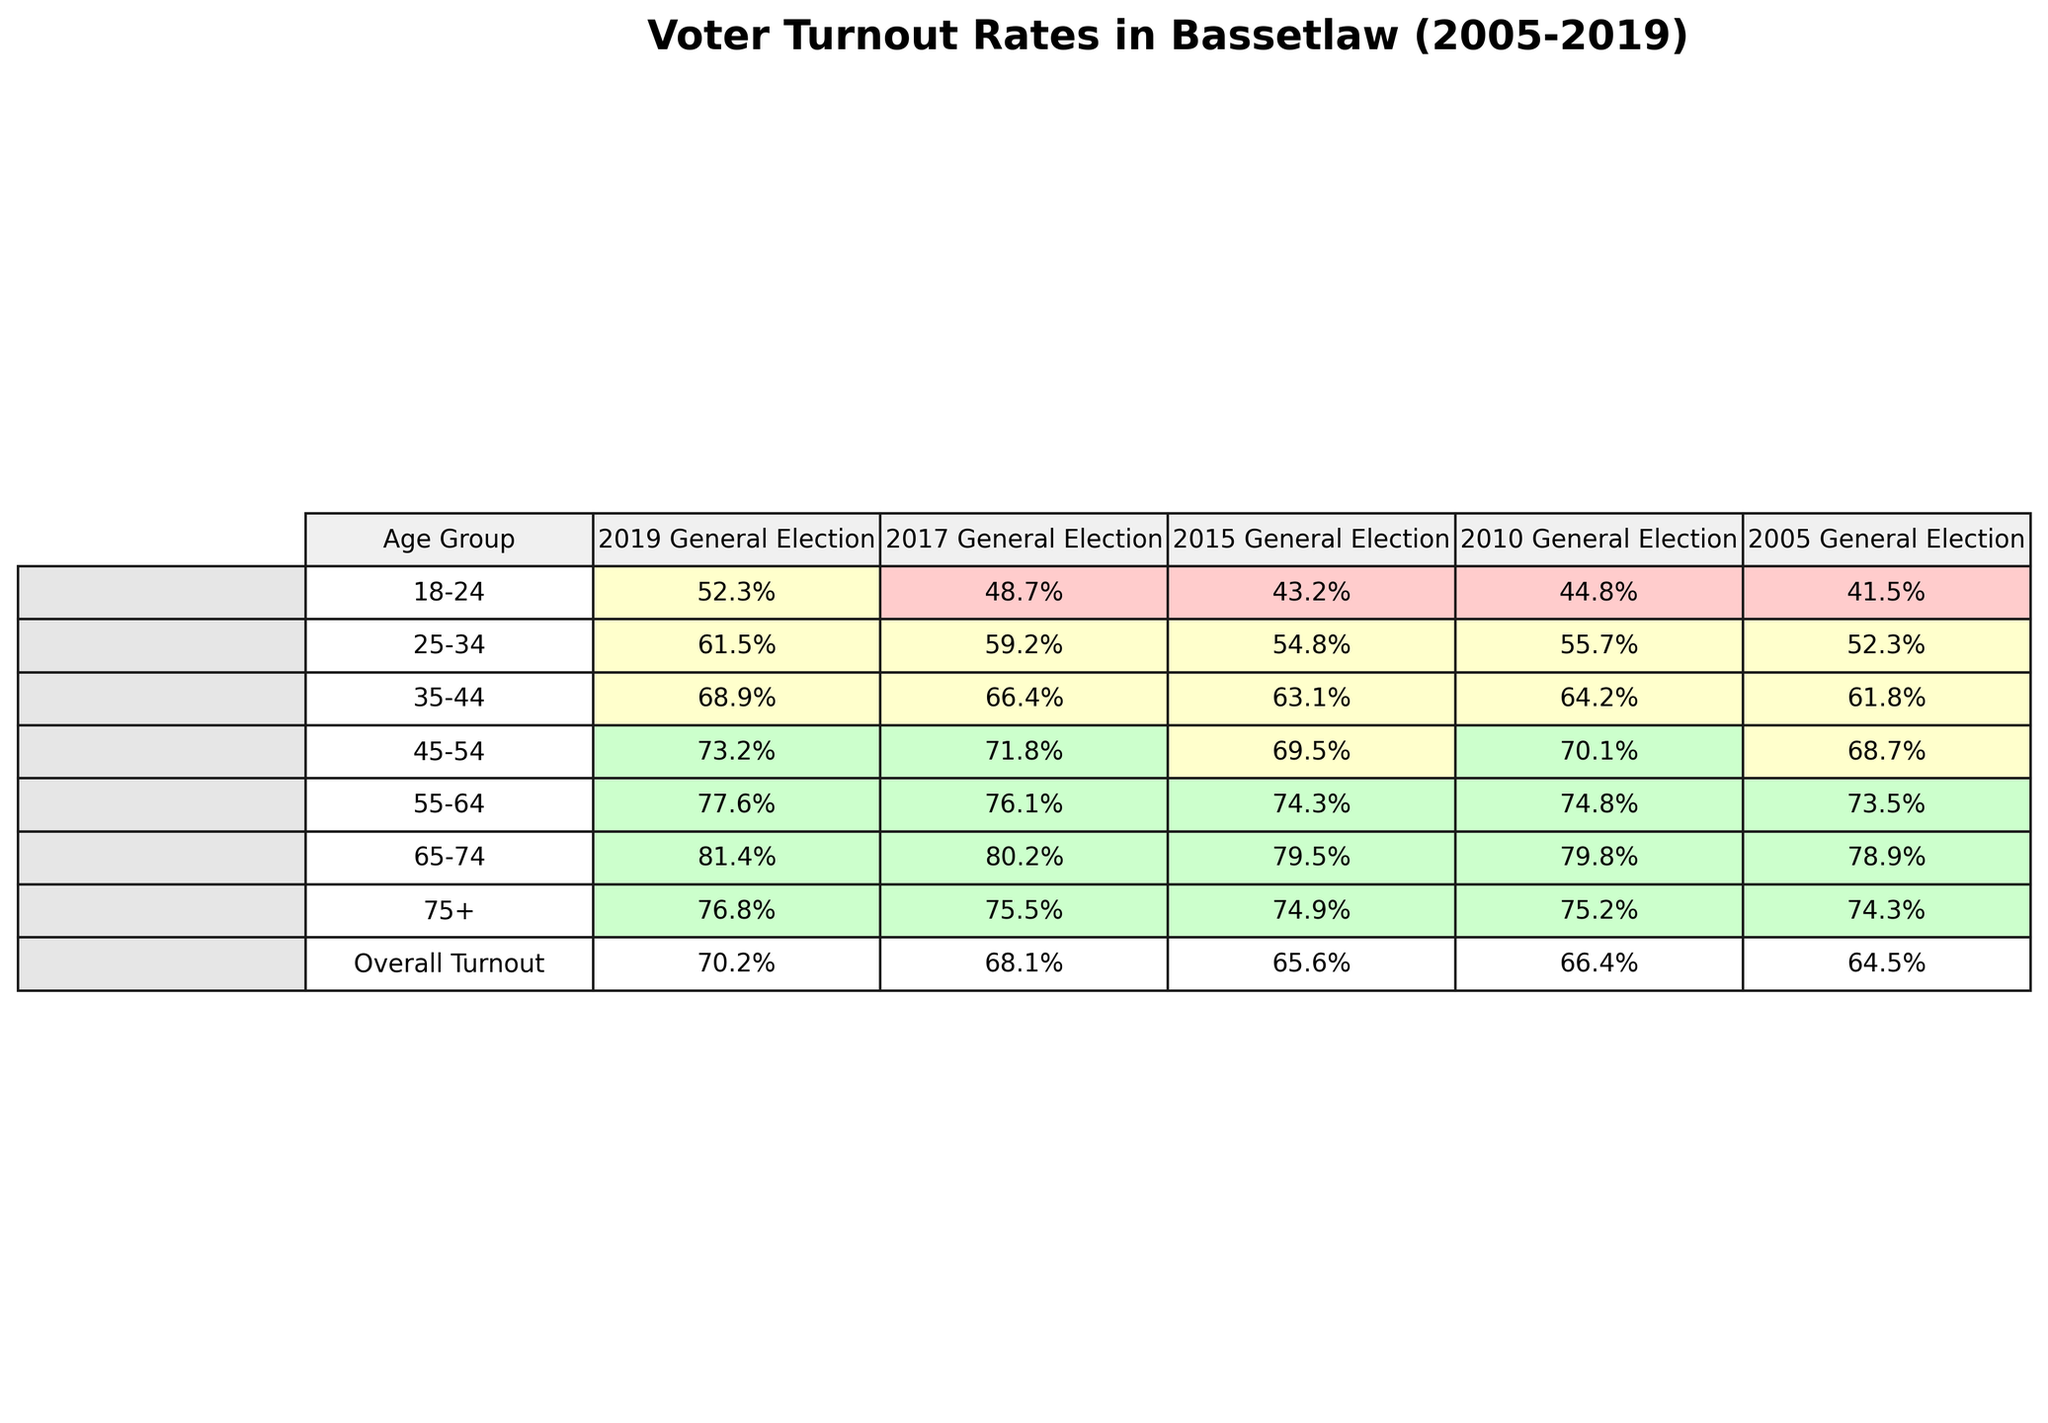What was the voter turnout percentage for the 18-24 age group in the 2019 General Election? By referring to the table, we can find the entry under the "18-24" row and the "2019 General Election" column, which shows 52.3%.
Answer: 52.3% Which age group had the highest voter turnout in the 2017 General Election? The table shows that the "65-74" age group had a voter turnout of 80.2%, which is higher than any other group listed for that year.
Answer: 65-74 What is the difference in voter turnout between the 25-34 and 45-54 age groups in the 2015 General Election? The turnout for 25-34 is 54.8% and for 45-54 is 69.5%. The difference is 69.5% - 54.8% = 14.7%.
Answer: 14.7% What was the overall voter turnout in the 2010 General Election? Looking at the last row of the table under the "2010 General Election" column, the overall turnout is shown as 66.4%.
Answer: 66.4% Did the voter turnout for the 55-64 age group increase from the 2010 to the 2019 General Election? The turnout for 55-64 in 2010 is 74.8% and in 2019 it is 77.6%. Since 77.6% is greater than 74.8%, the turnout indeed increased.
Answer: Yes What was the average voter turnout of the 75+ age group across all the elections listed? The percentages for the 75+ group are 76.8%, 75.5%, 74.9%, 75.2%, and 74.3%. To find the average, sum these values (376.7%) and divide by 5, which equals 75.34%.
Answer: 75.34% Which age group saw the smallest increase in voter turnout from the 2015 to the 2019 General Election? For each group, we calculate the increase: 18-24 (52.3% - 43.2% = 9.1%), 25-34 (61.5% - 54.8% = 6.7%), 35-44 (68.9% - 63.1% = 5.8%), 45-54 (73.2% - 69.5% = 3.7%), 55-64 (77.6% - 74.3% = 3.3%), 65-74 (81.4% - 79.5% = 1.9%), 75+ (76.8% - 74.9% = 1.9%). The smallest increase is 1.9% for the 65-74 and 75+ age groups.
Answer: 65-74 and 75+ What was the overall voter turnout for the elections from 2005 to 2019, and how did it trend over these years? The overall turnouts from 2005 to 2019 are 64.5%, 66.4%, 65.6%, 68.1%, and 70.2%. To determine the trend, note the general increase from 64.5% to 70.2%, which indicates an upward trend.
Answer: Upward trend In which election did the 35-44 age group display a turnout of 63.1%? Referring to the table for the 35-44 age group, we see the turnout of 63.1% is listed for the 2015 General Election.
Answer: 2015 General Election 